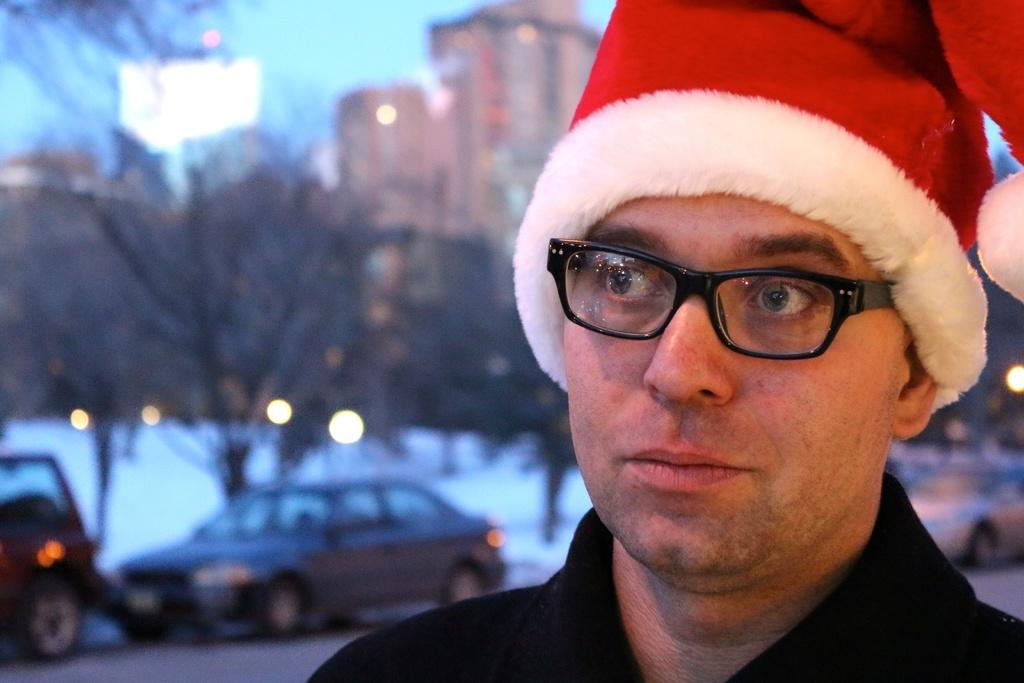What can be seen in the image? There is a person in the image. Can you describe the person's attire? The person is wearing a cap. What can be observed about the background of the image? The background of the image is blurred. What types of objects can be seen in the background? Cars, lights, trees, and buildings are visible in the background. What type of sack is being used by the person to guide the boundary in the image? There is no sack or boundary present in the image, and the person is not guiding anything. 